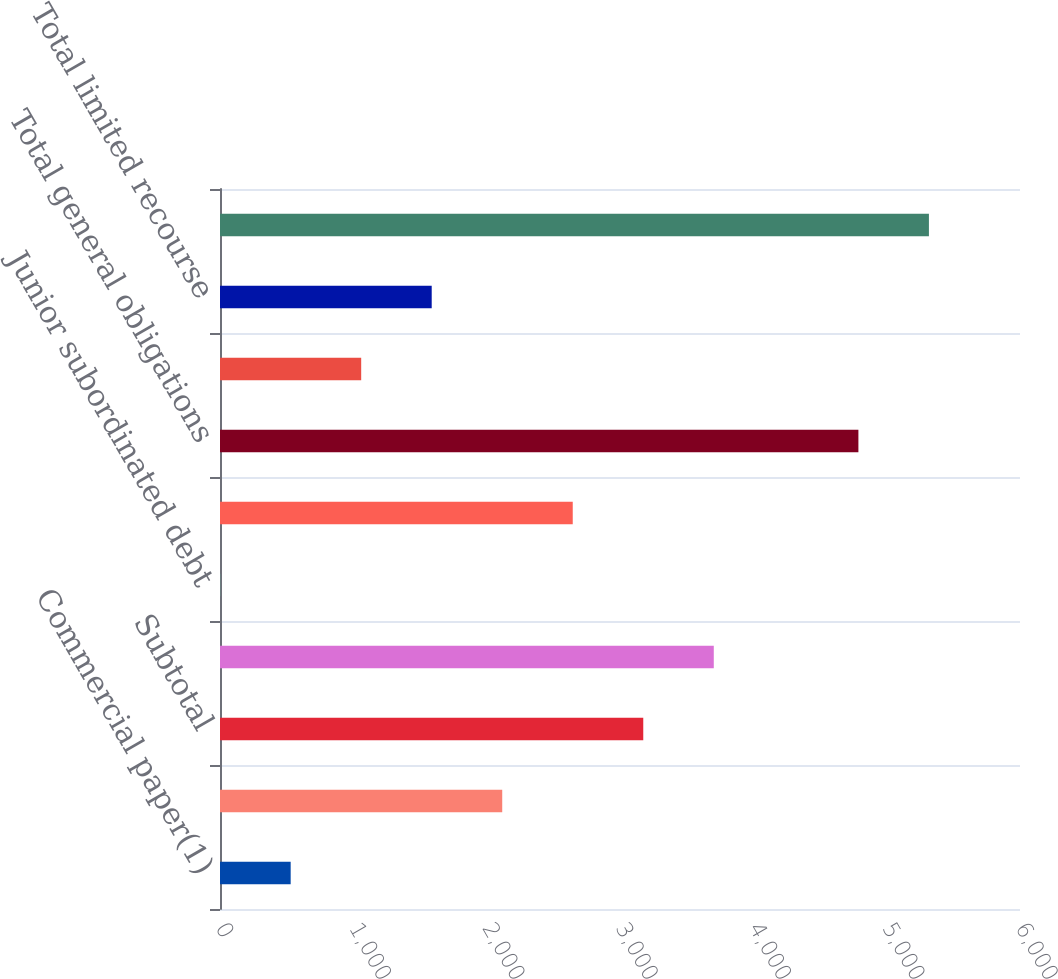Convert chart to OTSL. <chart><loc_0><loc_0><loc_500><loc_500><bar_chart><fcel>Commercial paper(1)<fcel>Current portion of long-term<fcel>Subtotal<fcel>Senior debt(3)<fcel>Junior subordinated debt<fcel>Surplus notes(4)<fcel>Total general obligations<fcel>Long-term debt<fcel>Total limited recourse<fcel>Total borrowings<nl><fcel>530.04<fcel>2116.7<fcel>3174.48<fcel>3703.37<fcel>1.15<fcel>2645.59<fcel>4788<fcel>1058.93<fcel>1587.82<fcel>5316.89<nl></chart> 